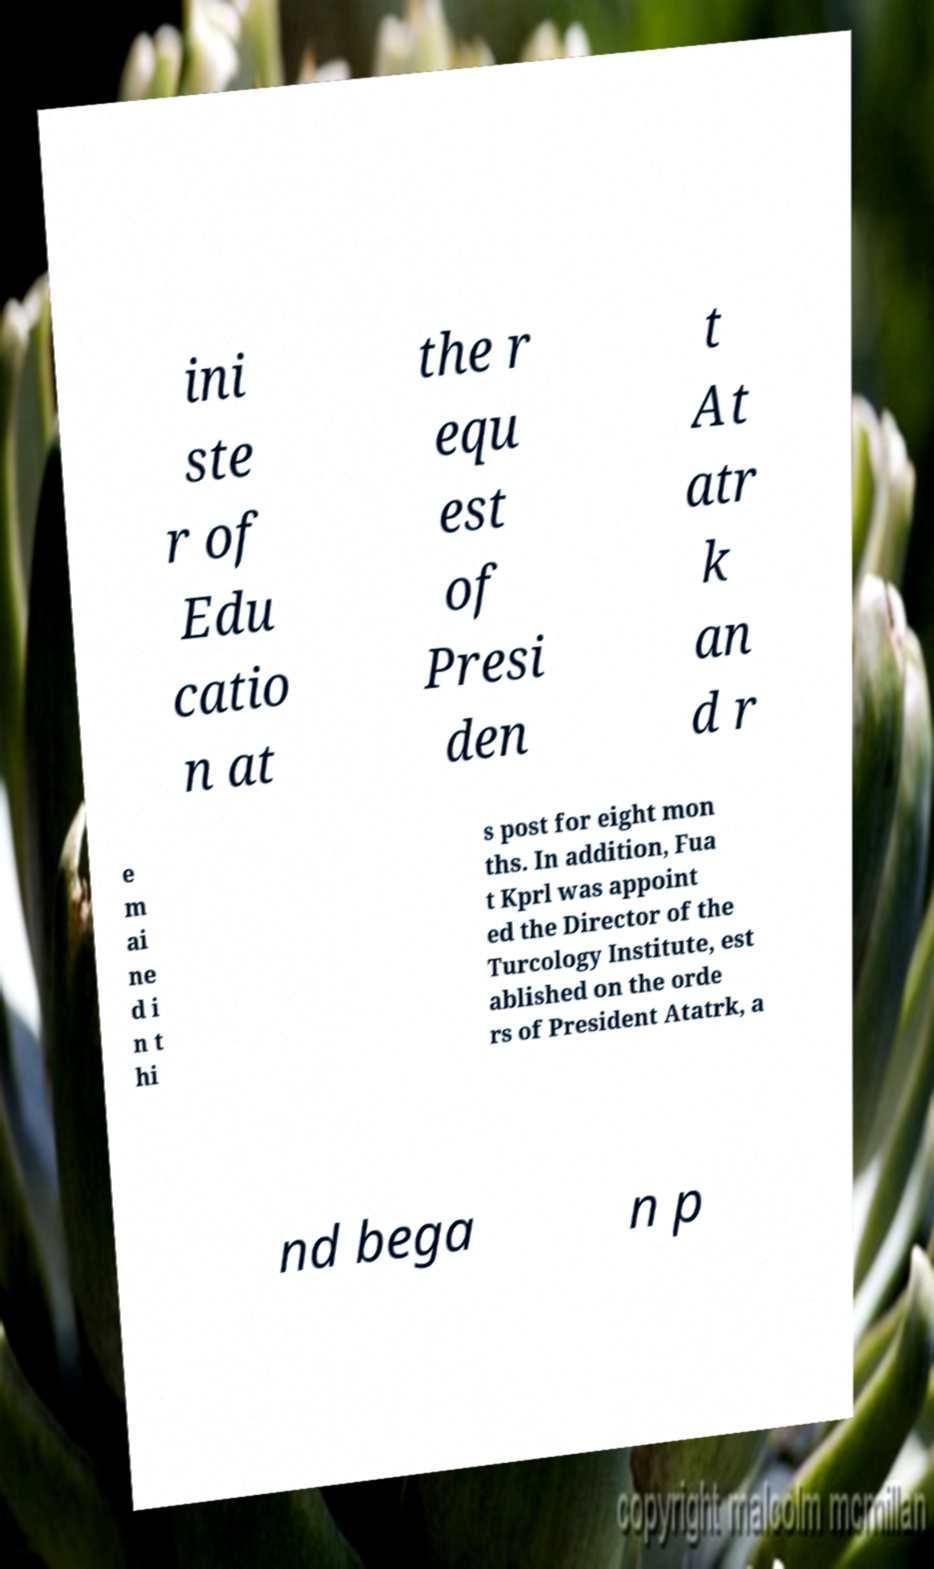What messages or text are displayed in this image? I need them in a readable, typed format. ini ste r of Edu catio n at the r equ est of Presi den t At atr k an d r e m ai ne d i n t hi s post for eight mon ths. In addition, Fua t Kprl was appoint ed the Director of the Turcology Institute, est ablished on the orde rs of President Atatrk, a nd bega n p 